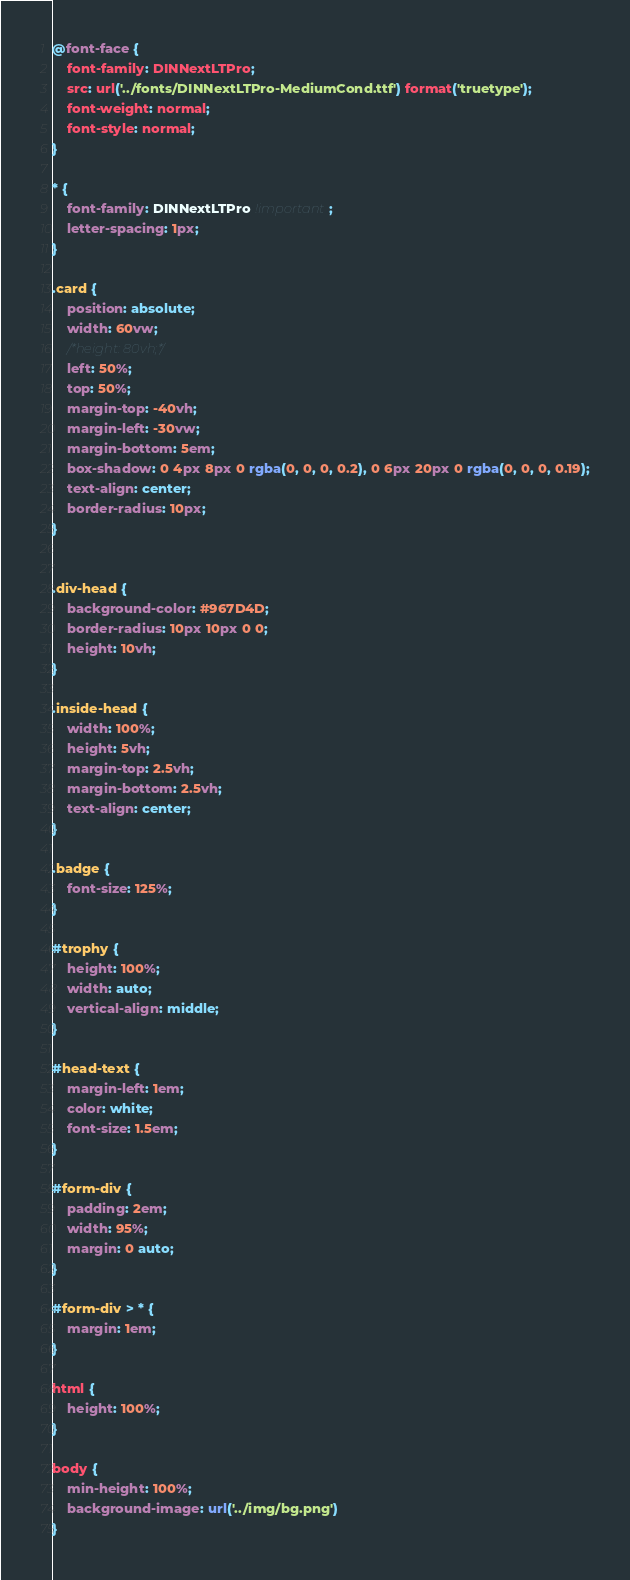Convert code to text. <code><loc_0><loc_0><loc_500><loc_500><_CSS_>
@font-face {
    font-family: DINNextLTPro;
    src: url('../fonts/DINNextLTPro-MediumCond.ttf') format('truetype');
    font-weight: normal;
    font-style: normal;
}

* {
    font-family: DINNextLTPro !important;
    letter-spacing: 1px;
}

.card {
	position: absolute;
	width: 60vw;
	/*height: 80vh;*/
	left: 50%;
	top: 50%;
	margin-top: -40vh;
	margin-left: -30vw;
	margin-bottom: 5em;
	box-shadow: 0 4px 8px 0 rgba(0, 0, 0, 0.2), 0 6px 20px 0 rgba(0, 0, 0, 0.19);
	text-align: center;
	border-radius: 10px;
}


.div-head {
	background-color: #967D4D;
    border-radius: 10px 10px 0 0;
	height: 10vh;
}

.inside-head {
	width: 100%;
	height: 5vh;
	margin-top: 2.5vh;
	margin-bottom: 2.5vh;
    text-align: center;
}

.badge {
	font-size: 125%;
}

#trophy {
	height: 100%;
	width: auto;
	vertical-align: middle;
}

#head-text {
	margin-left: 1em;
	color: white;
	font-size: 1.5em;
}

#form-div {
	padding: 2em;
	width: 95%;
	margin: 0 auto;
}

#form-div > * {
	margin: 1em;
}

html {
	height: 100%;
}

body {
	min-height: 100%;
	background-image: url('../img/bg.png')
}
</code> 